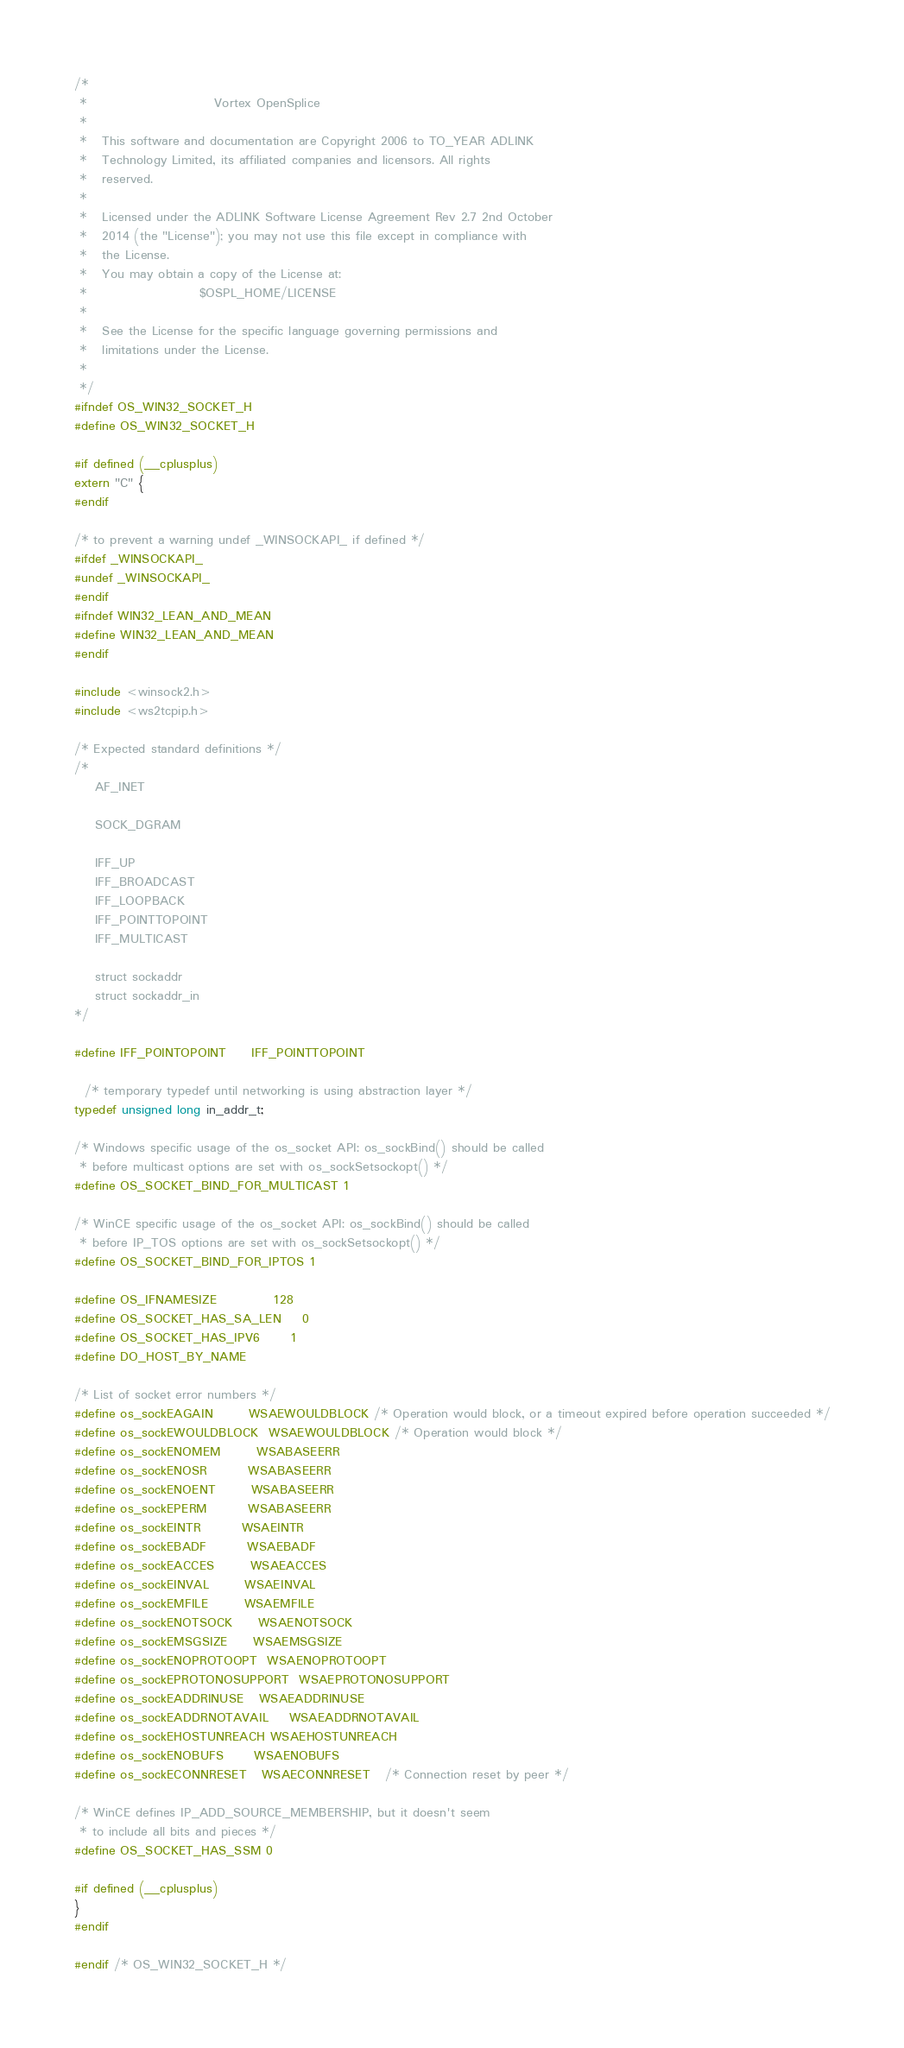<code> <loc_0><loc_0><loc_500><loc_500><_C_>/*
 *                         Vortex OpenSplice
 *
 *   This software and documentation are Copyright 2006 to TO_YEAR ADLINK
 *   Technology Limited, its affiliated companies and licensors. All rights
 *   reserved.
 *
 *   Licensed under the ADLINK Software License Agreement Rev 2.7 2nd October
 *   2014 (the "License"); you may not use this file except in compliance with
 *   the License.
 *   You may obtain a copy of the License at:
 *                      $OSPL_HOME/LICENSE
 *
 *   See the License for the specific language governing permissions and
 *   limitations under the License.
 *
 */
#ifndef OS_WIN32_SOCKET_H
#define OS_WIN32_SOCKET_H

#if defined (__cplusplus)
extern "C" {
#endif

/* to prevent a warning undef _WINSOCKAPI_ if defined */
#ifdef _WINSOCKAPI_
#undef _WINSOCKAPI_
#endif
#ifndef WIN32_LEAN_AND_MEAN
#define WIN32_LEAN_AND_MEAN
#endif

#include <winsock2.h>
#include <ws2tcpip.h>

/* Expected standard definitions */
/*
    AF_INET

    SOCK_DGRAM

    IFF_UP
    IFF_BROADCAST
    IFF_LOOPBACK
    IFF_POINTTOPOINT
    IFF_MULTICAST

    struct sockaddr
    struct sockaddr_in
*/

#define IFF_POINTOPOINT     IFF_POINTTOPOINT

  /* temporary typedef until networking is using abstraction layer */
typedef unsigned long in_addr_t;

/* Windows specific usage of the os_socket API: os_sockBind() should be called
 * before multicast options are set with os_sockSetsockopt() */
#define OS_SOCKET_BIND_FOR_MULTICAST 1

/* WinCE specific usage of the os_socket API: os_sockBind() should be called
 * before IP_TOS options are set with os_sockSetsockopt() */
#define OS_SOCKET_BIND_FOR_IPTOS 1

#define OS_IFNAMESIZE           128
#define OS_SOCKET_HAS_SA_LEN    0
#define OS_SOCKET_HAS_IPV6      1
#define DO_HOST_BY_NAME

/* List of socket error numbers */
#define os_sockEAGAIN       WSAEWOULDBLOCK /* Operation would block, or a timeout expired before operation succeeded */
#define os_sockEWOULDBLOCK  WSAEWOULDBLOCK /* Operation would block */
#define os_sockENOMEM       WSABASEERR
#define os_sockENOSR        WSABASEERR
#define os_sockENOENT       WSABASEERR
#define os_sockEPERM        WSABASEERR
#define os_sockEINTR        WSAEINTR
#define os_sockEBADF        WSAEBADF
#define os_sockEACCES       WSAEACCES
#define os_sockEINVAL       WSAEINVAL
#define os_sockEMFILE       WSAEMFILE
#define os_sockENOTSOCK     WSAENOTSOCK
#define os_sockEMSGSIZE     WSAEMSGSIZE
#define os_sockENOPROTOOPT  WSAENOPROTOOPT
#define os_sockEPROTONOSUPPORT  WSAEPROTONOSUPPORT
#define os_sockEADDRINUSE   WSAEADDRINUSE
#define os_sockEADDRNOTAVAIL    WSAEADDRNOTAVAIL
#define os_sockEHOSTUNREACH WSAEHOSTUNREACH
#define os_sockENOBUFS      WSAENOBUFS
#define os_sockECONNRESET   WSAECONNRESET   /* Connection reset by peer */

/* WinCE defines IP_ADD_SOURCE_MEMBERSHIP, but it doesn't seem
 * to include all bits and pieces */
#define OS_SOCKET_HAS_SSM 0

#if defined (__cplusplus)
}
#endif

#endif /* OS_WIN32_SOCKET_H */
</code> 